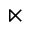<formula> <loc_0><loc_0><loc_500><loc_500>\ltimes</formula> 